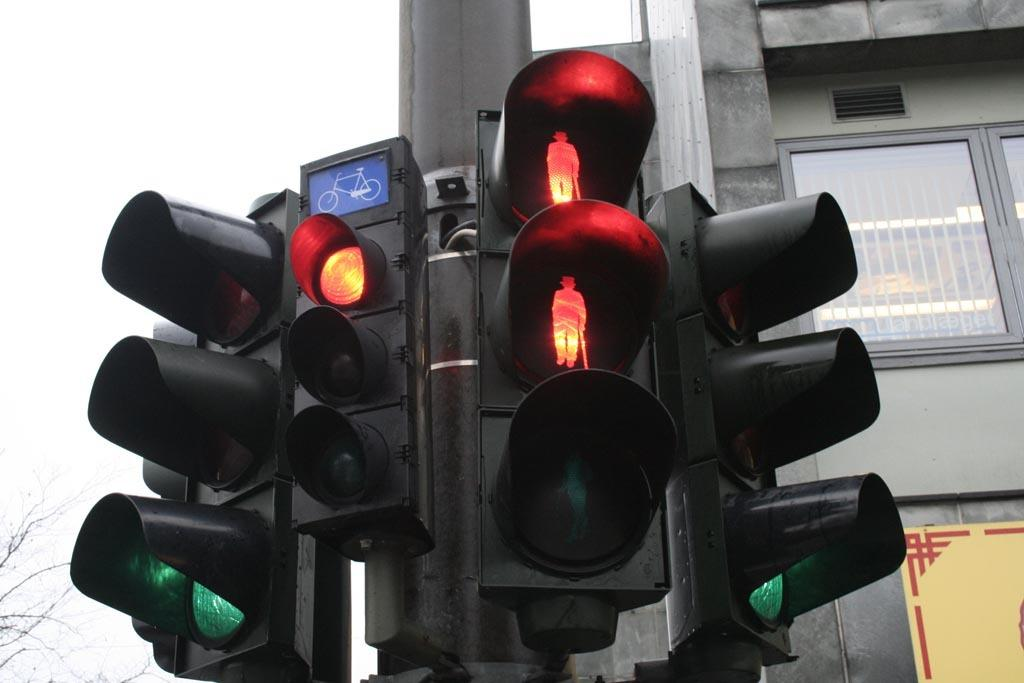What type of traffic control devices are present in the image? There are signal lights in the image. What other object can be seen in the image related to information or direction? There is a signboard in the image. What structure is supporting the signal lights and signboard? There is a pole in the image. What type of man-made structure is visible in the image? There is a building in the image. What type of natural element is present in the image? There is a tree in the image. What part of the natural environment is visible in the image? The sky is visible in the image. What other object can be seen in the image related to communication or display? There is a board in the image. What can be seen through a window in the image? Lights are visible through a window in the image. Can you describe the farmer's outfit in the image? There is no farmer present in the image. What effect does the tramp have on the signal lights in the image? There is no tramp present in the image, so it cannot have any effect on the signal lights. 